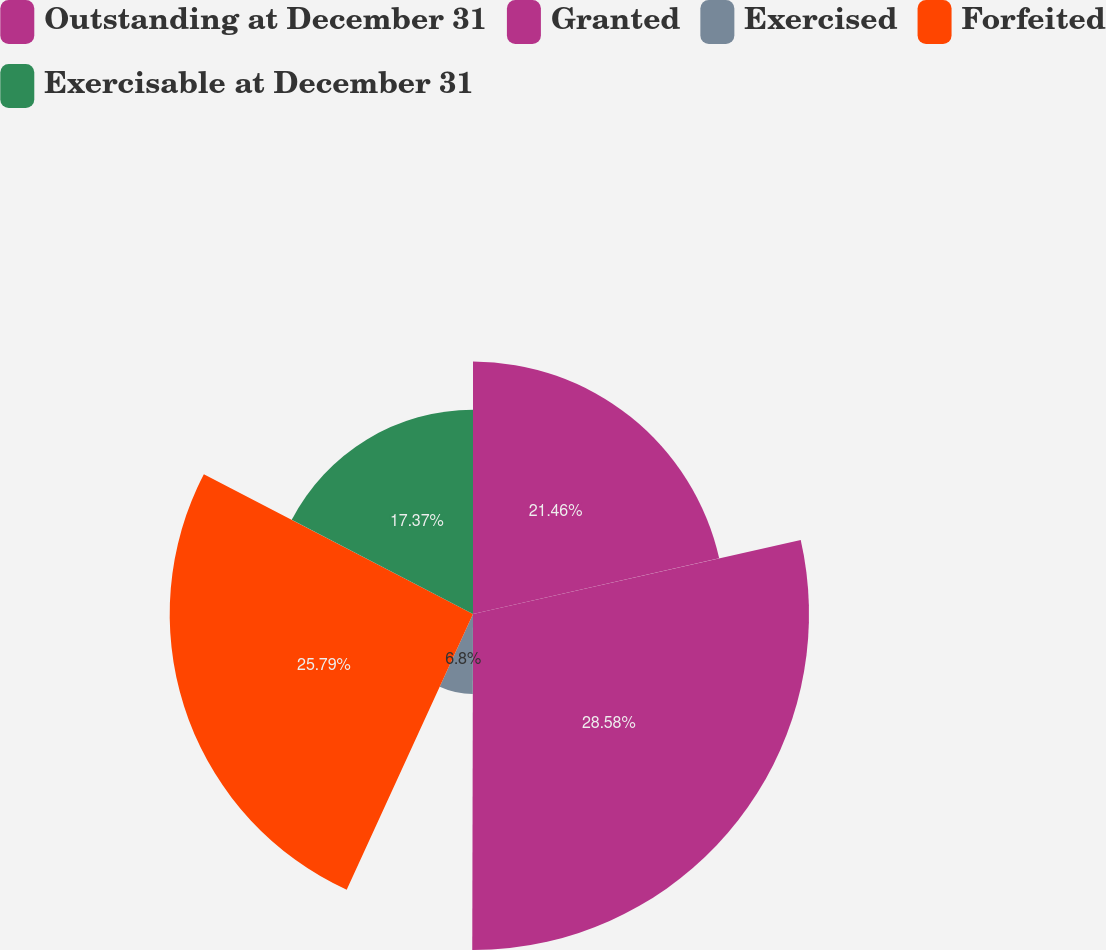Convert chart to OTSL. <chart><loc_0><loc_0><loc_500><loc_500><pie_chart><fcel>Outstanding at December 31<fcel>Granted<fcel>Exercised<fcel>Forfeited<fcel>Exercisable at December 31<nl><fcel>21.46%<fcel>28.57%<fcel>6.8%<fcel>25.79%<fcel>17.37%<nl></chart> 